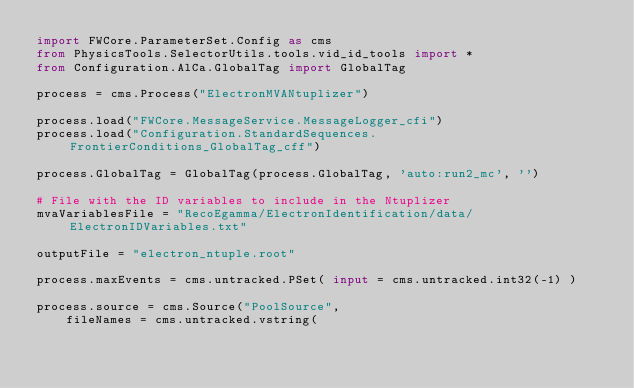<code> <loc_0><loc_0><loc_500><loc_500><_Python_>import FWCore.ParameterSet.Config as cms
from PhysicsTools.SelectorUtils.tools.vid_id_tools import *
from Configuration.AlCa.GlobalTag import GlobalTag

process = cms.Process("ElectronMVANtuplizer")

process.load("FWCore.MessageService.MessageLogger_cfi")
process.load("Configuration.StandardSequences.FrontierConditions_GlobalTag_cff")

process.GlobalTag = GlobalTag(process.GlobalTag, 'auto:run2_mc', '')

# File with the ID variables to include in the Ntuplizer
mvaVariablesFile = "RecoEgamma/ElectronIdentification/data/ElectronIDVariables.txt"

outputFile = "electron_ntuple.root"

process.maxEvents = cms.untracked.PSet( input = cms.untracked.int32(-1) )

process.source = cms.Source("PoolSource",
    fileNames = cms.untracked.vstring(</code> 